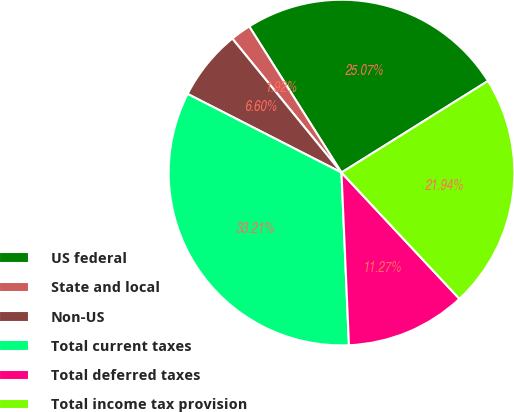<chart> <loc_0><loc_0><loc_500><loc_500><pie_chart><fcel>US federal<fcel>State and local<fcel>Non-US<fcel>Total current taxes<fcel>Total deferred taxes<fcel>Total income tax provision<nl><fcel>25.07%<fcel>1.92%<fcel>6.6%<fcel>33.21%<fcel>11.27%<fcel>21.94%<nl></chart> 